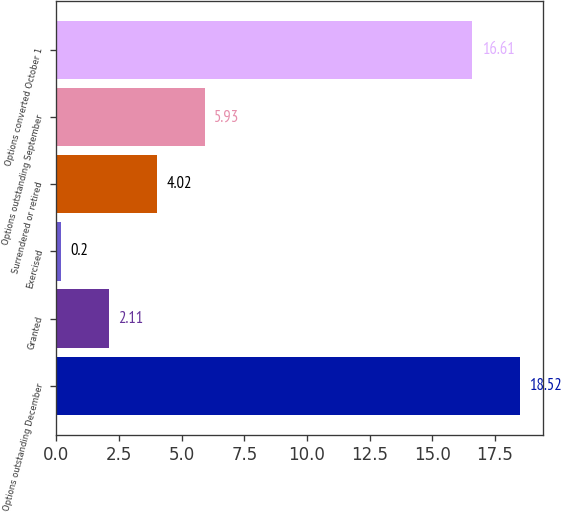Convert chart. <chart><loc_0><loc_0><loc_500><loc_500><bar_chart><fcel>Options outstanding December<fcel>Granted<fcel>Exercised<fcel>Surrendered or retired<fcel>Options outstanding September<fcel>Options converted October 1<nl><fcel>18.52<fcel>2.11<fcel>0.2<fcel>4.02<fcel>5.93<fcel>16.61<nl></chart> 